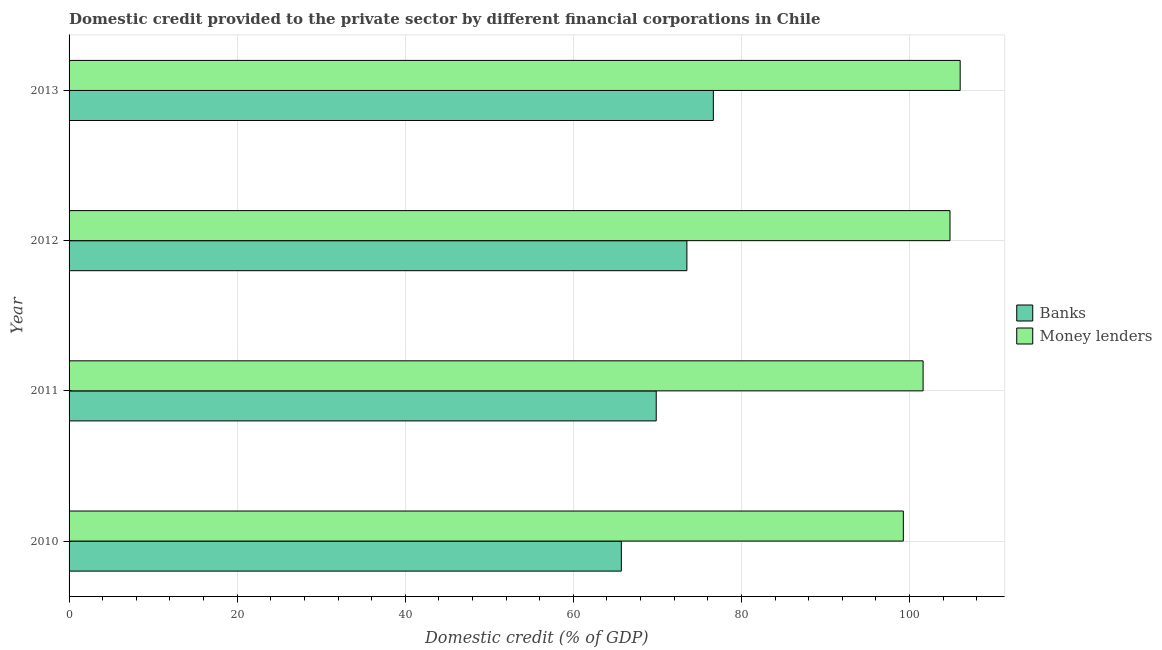How many groups of bars are there?
Offer a terse response. 4. Are the number of bars per tick equal to the number of legend labels?
Your answer should be compact. Yes. How many bars are there on the 4th tick from the top?
Ensure brevity in your answer.  2. What is the domestic credit provided by money lenders in 2010?
Ensure brevity in your answer.  99.27. Across all years, what is the maximum domestic credit provided by banks?
Provide a succinct answer. 76.66. Across all years, what is the minimum domestic credit provided by banks?
Your answer should be compact. 65.71. What is the total domestic credit provided by money lenders in the graph?
Make the answer very short. 411.73. What is the difference between the domestic credit provided by money lenders in 2010 and that in 2011?
Offer a terse response. -2.35. What is the difference between the domestic credit provided by banks in 2011 and the domestic credit provided by money lenders in 2010?
Your answer should be compact. -29.4. What is the average domestic credit provided by banks per year?
Your answer should be very brief. 71.44. In the year 2013, what is the difference between the domestic credit provided by money lenders and domestic credit provided by banks?
Give a very brief answer. 29.37. In how many years, is the domestic credit provided by banks greater than 104 %?
Offer a terse response. 0. What is the ratio of the domestic credit provided by banks in 2011 to that in 2012?
Ensure brevity in your answer.  0.95. Is the domestic credit provided by money lenders in 2011 less than that in 2012?
Your response must be concise. Yes. What is the difference between the highest and the second highest domestic credit provided by banks?
Give a very brief answer. 3.15. What is the difference between the highest and the lowest domestic credit provided by money lenders?
Make the answer very short. 6.76. In how many years, is the domestic credit provided by money lenders greater than the average domestic credit provided by money lenders taken over all years?
Provide a short and direct response. 2. Is the sum of the domestic credit provided by banks in 2012 and 2013 greater than the maximum domestic credit provided by money lenders across all years?
Keep it short and to the point. Yes. What does the 2nd bar from the top in 2011 represents?
Give a very brief answer. Banks. What does the 2nd bar from the bottom in 2012 represents?
Ensure brevity in your answer.  Money lenders. What is the difference between two consecutive major ticks on the X-axis?
Give a very brief answer. 20. Are the values on the major ticks of X-axis written in scientific E-notation?
Your answer should be compact. No. Does the graph contain any zero values?
Your answer should be compact. No. Where does the legend appear in the graph?
Provide a short and direct response. Center right. How many legend labels are there?
Provide a succinct answer. 2. How are the legend labels stacked?
Your response must be concise. Vertical. What is the title of the graph?
Give a very brief answer. Domestic credit provided to the private sector by different financial corporations in Chile. What is the label or title of the X-axis?
Your answer should be very brief. Domestic credit (% of GDP). What is the label or title of the Y-axis?
Give a very brief answer. Year. What is the Domestic credit (% of GDP) in Banks in 2010?
Your answer should be compact. 65.71. What is the Domestic credit (% of GDP) of Money lenders in 2010?
Your answer should be very brief. 99.27. What is the Domestic credit (% of GDP) in Banks in 2011?
Keep it short and to the point. 69.86. What is the Domestic credit (% of GDP) of Money lenders in 2011?
Provide a succinct answer. 101.62. What is the Domestic credit (% of GDP) of Banks in 2012?
Make the answer very short. 73.51. What is the Domestic credit (% of GDP) in Money lenders in 2012?
Offer a very short reply. 104.82. What is the Domestic credit (% of GDP) in Banks in 2013?
Your response must be concise. 76.66. What is the Domestic credit (% of GDP) in Money lenders in 2013?
Your answer should be very brief. 106.03. Across all years, what is the maximum Domestic credit (% of GDP) of Banks?
Your response must be concise. 76.66. Across all years, what is the maximum Domestic credit (% of GDP) in Money lenders?
Ensure brevity in your answer.  106.03. Across all years, what is the minimum Domestic credit (% of GDP) of Banks?
Ensure brevity in your answer.  65.71. Across all years, what is the minimum Domestic credit (% of GDP) in Money lenders?
Your answer should be very brief. 99.27. What is the total Domestic credit (% of GDP) of Banks in the graph?
Provide a short and direct response. 285.75. What is the total Domestic credit (% of GDP) of Money lenders in the graph?
Your response must be concise. 411.73. What is the difference between the Domestic credit (% of GDP) of Banks in 2010 and that in 2011?
Ensure brevity in your answer.  -4.15. What is the difference between the Domestic credit (% of GDP) of Money lenders in 2010 and that in 2011?
Your answer should be very brief. -2.35. What is the difference between the Domestic credit (% of GDP) in Banks in 2010 and that in 2012?
Your response must be concise. -7.8. What is the difference between the Domestic credit (% of GDP) in Money lenders in 2010 and that in 2012?
Ensure brevity in your answer.  -5.55. What is the difference between the Domestic credit (% of GDP) in Banks in 2010 and that in 2013?
Provide a succinct answer. -10.95. What is the difference between the Domestic credit (% of GDP) of Money lenders in 2010 and that in 2013?
Your response must be concise. -6.76. What is the difference between the Domestic credit (% of GDP) in Banks in 2011 and that in 2012?
Your answer should be compact. -3.65. What is the difference between the Domestic credit (% of GDP) of Money lenders in 2011 and that in 2012?
Provide a short and direct response. -3.2. What is the difference between the Domestic credit (% of GDP) of Banks in 2011 and that in 2013?
Make the answer very short. -6.8. What is the difference between the Domestic credit (% of GDP) of Money lenders in 2011 and that in 2013?
Make the answer very short. -4.41. What is the difference between the Domestic credit (% of GDP) in Banks in 2012 and that in 2013?
Your answer should be compact. -3.15. What is the difference between the Domestic credit (% of GDP) of Money lenders in 2012 and that in 2013?
Your response must be concise. -1.21. What is the difference between the Domestic credit (% of GDP) of Banks in 2010 and the Domestic credit (% of GDP) of Money lenders in 2011?
Ensure brevity in your answer.  -35.91. What is the difference between the Domestic credit (% of GDP) in Banks in 2010 and the Domestic credit (% of GDP) in Money lenders in 2012?
Your response must be concise. -39.11. What is the difference between the Domestic credit (% of GDP) of Banks in 2010 and the Domestic credit (% of GDP) of Money lenders in 2013?
Offer a very short reply. -40.32. What is the difference between the Domestic credit (% of GDP) in Banks in 2011 and the Domestic credit (% of GDP) in Money lenders in 2012?
Give a very brief answer. -34.96. What is the difference between the Domestic credit (% of GDP) of Banks in 2011 and the Domestic credit (% of GDP) of Money lenders in 2013?
Keep it short and to the point. -36.17. What is the difference between the Domestic credit (% of GDP) in Banks in 2012 and the Domestic credit (% of GDP) in Money lenders in 2013?
Your answer should be compact. -32.52. What is the average Domestic credit (% of GDP) in Banks per year?
Give a very brief answer. 71.44. What is the average Domestic credit (% of GDP) in Money lenders per year?
Your answer should be compact. 102.93. In the year 2010, what is the difference between the Domestic credit (% of GDP) of Banks and Domestic credit (% of GDP) of Money lenders?
Provide a succinct answer. -33.55. In the year 2011, what is the difference between the Domestic credit (% of GDP) in Banks and Domestic credit (% of GDP) in Money lenders?
Ensure brevity in your answer.  -31.76. In the year 2012, what is the difference between the Domestic credit (% of GDP) of Banks and Domestic credit (% of GDP) of Money lenders?
Keep it short and to the point. -31.3. In the year 2013, what is the difference between the Domestic credit (% of GDP) of Banks and Domestic credit (% of GDP) of Money lenders?
Keep it short and to the point. -29.37. What is the ratio of the Domestic credit (% of GDP) in Banks in 2010 to that in 2011?
Your answer should be compact. 0.94. What is the ratio of the Domestic credit (% of GDP) of Money lenders in 2010 to that in 2011?
Offer a very short reply. 0.98. What is the ratio of the Domestic credit (% of GDP) in Banks in 2010 to that in 2012?
Your response must be concise. 0.89. What is the ratio of the Domestic credit (% of GDP) of Money lenders in 2010 to that in 2012?
Offer a terse response. 0.95. What is the ratio of the Domestic credit (% of GDP) in Banks in 2010 to that in 2013?
Make the answer very short. 0.86. What is the ratio of the Domestic credit (% of GDP) in Money lenders in 2010 to that in 2013?
Provide a short and direct response. 0.94. What is the ratio of the Domestic credit (% of GDP) in Banks in 2011 to that in 2012?
Provide a short and direct response. 0.95. What is the ratio of the Domestic credit (% of GDP) in Money lenders in 2011 to that in 2012?
Make the answer very short. 0.97. What is the ratio of the Domestic credit (% of GDP) in Banks in 2011 to that in 2013?
Your answer should be very brief. 0.91. What is the ratio of the Domestic credit (% of GDP) in Money lenders in 2011 to that in 2013?
Ensure brevity in your answer.  0.96. What is the ratio of the Domestic credit (% of GDP) in Banks in 2012 to that in 2013?
Offer a very short reply. 0.96. What is the ratio of the Domestic credit (% of GDP) of Money lenders in 2012 to that in 2013?
Your response must be concise. 0.99. What is the difference between the highest and the second highest Domestic credit (% of GDP) of Banks?
Keep it short and to the point. 3.15. What is the difference between the highest and the second highest Domestic credit (% of GDP) of Money lenders?
Provide a succinct answer. 1.21. What is the difference between the highest and the lowest Domestic credit (% of GDP) of Banks?
Make the answer very short. 10.95. What is the difference between the highest and the lowest Domestic credit (% of GDP) of Money lenders?
Offer a terse response. 6.76. 